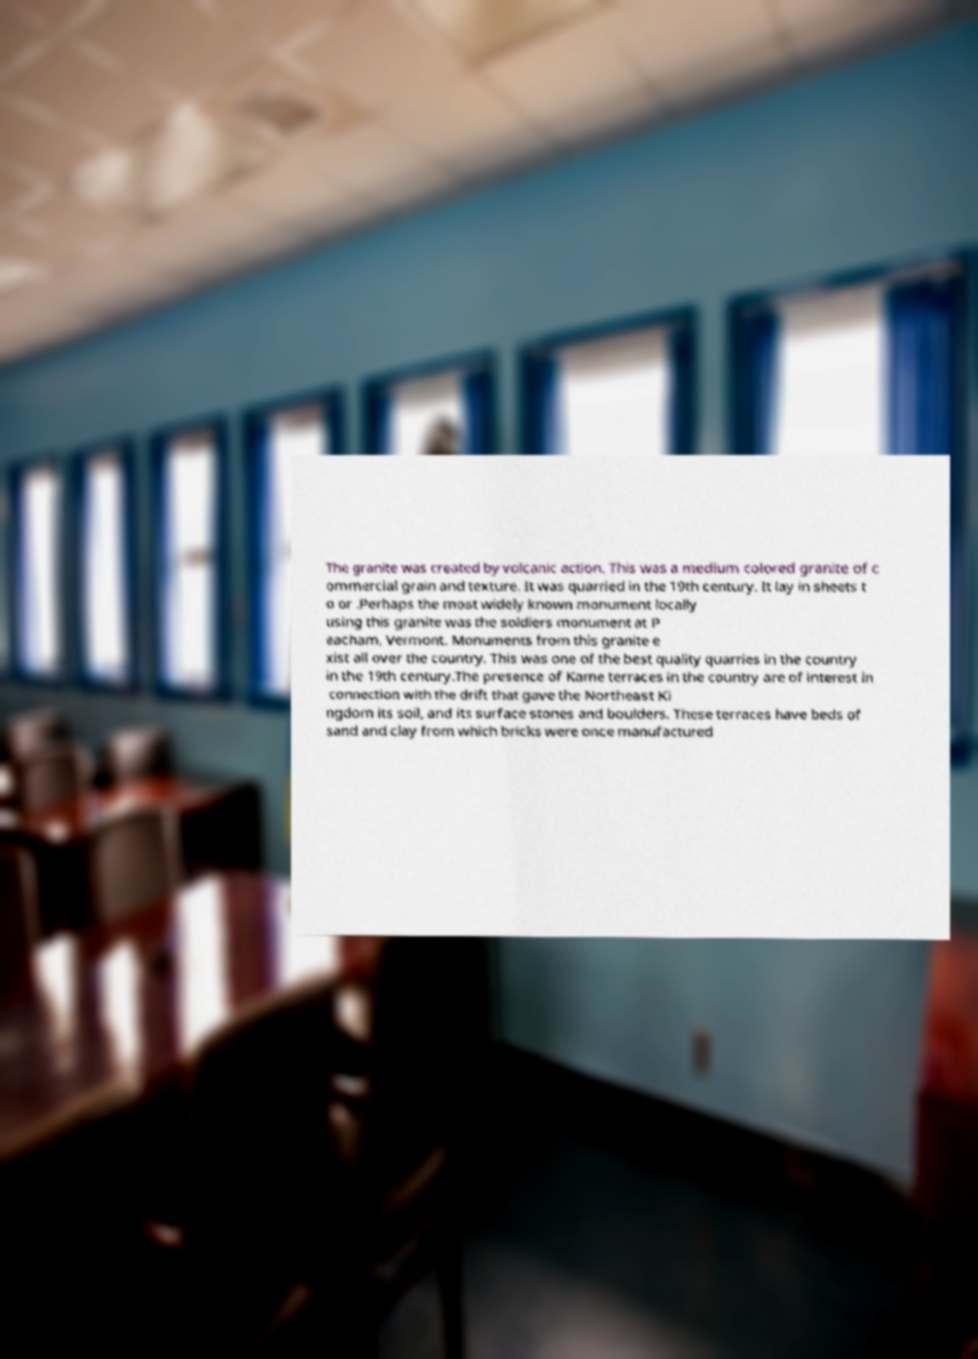Can you read and provide the text displayed in the image?This photo seems to have some interesting text. Can you extract and type it out for me? The granite was created by volcanic action. This was a medium colored granite of c ommercial grain and texture. It was quarried in the 19th century. It lay in sheets t o or .Perhaps the most widely known monument locally using this granite was the soldiers monument at P eacham, Vermont. Monuments from this granite e xist all over the country. This was one of the best quality quarries in the country in the 19th century.The presence of Kame terraces in the country are of interest in connection with the drift that gave the Northeast Ki ngdom its soil, and its surface stones and boulders. These terraces have beds of sand and clay from which bricks were once manufactured 